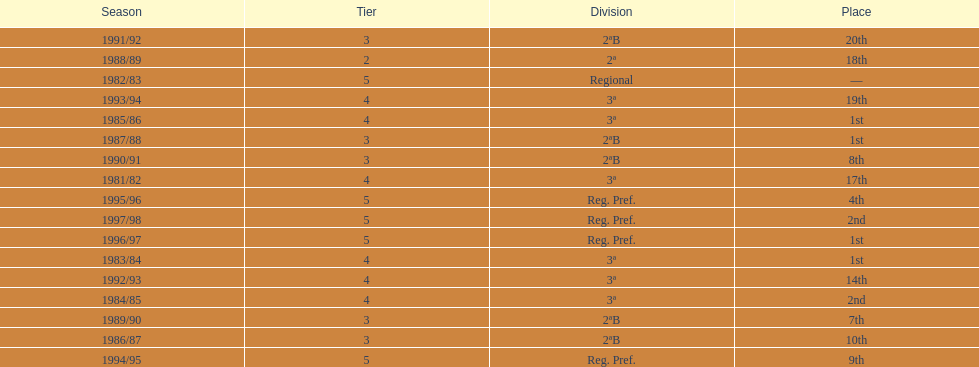Could you parse the entire table? {'header': ['Season', 'Tier', 'Division', 'Place'], 'rows': [['1991/92', '3', '2ªB', '20th'], ['1988/89', '2', '2ª', '18th'], ['1982/83', '5', 'Regional', '—'], ['1993/94', '4', '3ª', '19th'], ['1985/86', '4', '3ª', '1st'], ['1987/88', '3', '2ªB', '1st'], ['1990/91', '3', '2ªB', '8th'], ['1981/82', '4', '3ª', '17th'], ['1995/96', '5', 'Reg. Pref.', '4th'], ['1997/98', '5', 'Reg. Pref.', '2nd'], ['1996/97', '5', 'Reg. Pref.', '1st'], ['1983/84', '4', '3ª', '1st'], ['1992/93', '4', '3ª', '14th'], ['1984/85', '4', '3ª', '2nd'], ['1989/90', '3', '2ªB', '7th'], ['1986/87', '3', '2ªB', '10th'], ['1994/95', '5', 'Reg. Pref.', '9th']]} What were the number of times second place was earned? 2. 